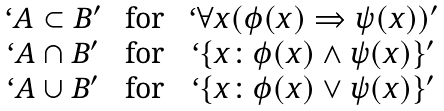<formula> <loc_0><loc_0><loc_500><loc_500>\begin{matrix} ` { A } \subset { B } \rq & \text { for } & ` \forall x ( \phi ( x ) \Rightarrow \psi ( x ) ) \rq \\ ` { A } \cap { B } \rq & \text { for } & ` \{ x \colon \phi ( x ) \wedge \psi ( x ) \} \rq \\ ` { A } \cup { B } \rq & \text { for } & ` \{ x \colon \phi ( x ) \vee \psi ( x ) \} \rq \\ \end{matrix}</formula> 